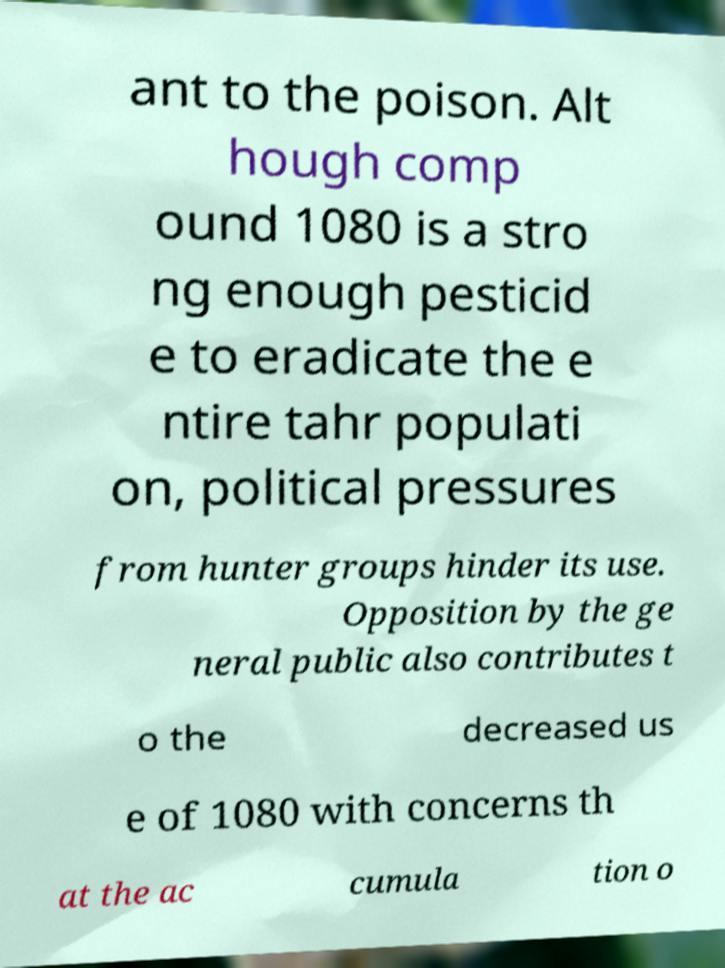Can you accurately transcribe the text from the provided image for me? ant to the poison. Alt hough comp ound 1080 is a stro ng enough pesticid e to eradicate the e ntire tahr populati on, political pressures from hunter groups hinder its use. Opposition by the ge neral public also contributes t o the decreased us e of 1080 with concerns th at the ac cumula tion o 